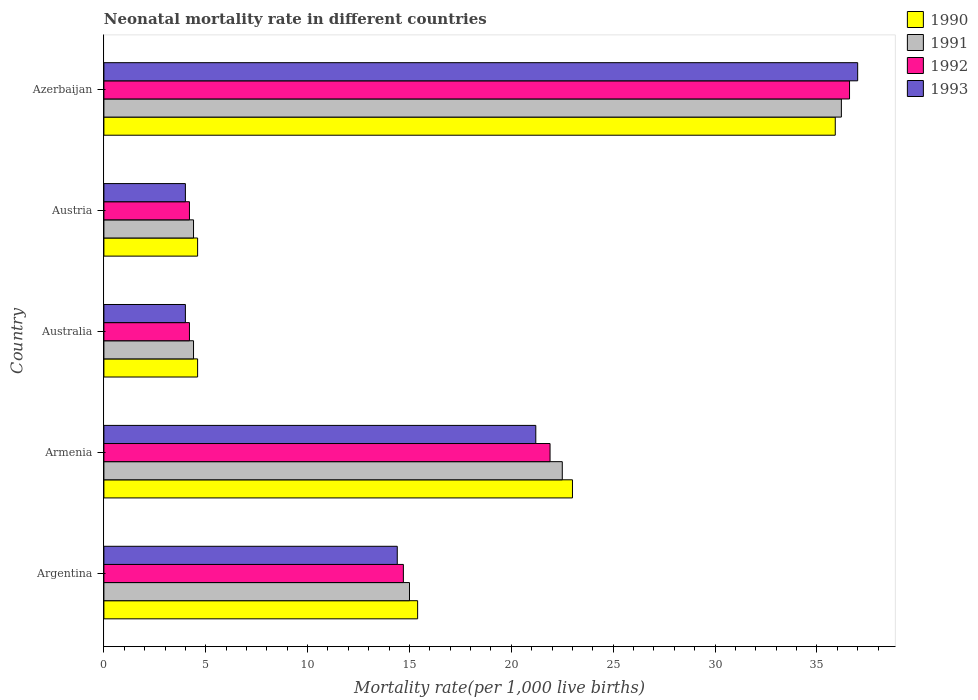How many different coloured bars are there?
Your answer should be very brief. 4. How many groups of bars are there?
Your response must be concise. 5. Are the number of bars per tick equal to the number of legend labels?
Keep it short and to the point. Yes. How many bars are there on the 3rd tick from the top?
Make the answer very short. 4. How many bars are there on the 4th tick from the bottom?
Your answer should be compact. 4. In how many cases, is the number of bars for a given country not equal to the number of legend labels?
Make the answer very short. 0. What is the neonatal mortality rate in 1992 in Australia?
Offer a terse response. 4.2. Across all countries, what is the maximum neonatal mortality rate in 1990?
Provide a short and direct response. 35.9. In which country was the neonatal mortality rate in 1993 maximum?
Make the answer very short. Azerbaijan. What is the total neonatal mortality rate in 1991 in the graph?
Your answer should be very brief. 82.5. What is the difference between the neonatal mortality rate in 1992 in Armenia and that in Austria?
Give a very brief answer. 17.7. What is the average neonatal mortality rate in 1993 per country?
Keep it short and to the point. 16.12. What is the difference between the neonatal mortality rate in 1993 and neonatal mortality rate in 1990 in Australia?
Make the answer very short. -0.6. In how many countries, is the neonatal mortality rate in 1992 greater than 22 ?
Provide a short and direct response. 1. What is the ratio of the neonatal mortality rate in 1992 in Argentina to that in Azerbaijan?
Give a very brief answer. 0.4. Is the difference between the neonatal mortality rate in 1993 in Armenia and Australia greater than the difference between the neonatal mortality rate in 1990 in Armenia and Australia?
Give a very brief answer. No. What is the difference between the highest and the second highest neonatal mortality rate in 1991?
Offer a terse response. 13.7. What is the difference between the highest and the lowest neonatal mortality rate in 1993?
Provide a succinct answer. 33. Is the sum of the neonatal mortality rate in 1991 in Austria and Azerbaijan greater than the maximum neonatal mortality rate in 1992 across all countries?
Make the answer very short. Yes. Is it the case that in every country, the sum of the neonatal mortality rate in 1992 and neonatal mortality rate in 1993 is greater than the sum of neonatal mortality rate in 1990 and neonatal mortality rate in 1991?
Provide a short and direct response. No. What does the 1st bar from the bottom in Armenia represents?
Provide a short and direct response. 1990. Does the graph contain any zero values?
Your response must be concise. No. Does the graph contain grids?
Your answer should be compact. No. Where does the legend appear in the graph?
Your response must be concise. Top right. What is the title of the graph?
Your answer should be compact. Neonatal mortality rate in different countries. Does "1992" appear as one of the legend labels in the graph?
Provide a succinct answer. Yes. What is the label or title of the X-axis?
Provide a succinct answer. Mortality rate(per 1,0 live births). What is the Mortality rate(per 1,000 live births) in 1991 in Argentina?
Give a very brief answer. 15. What is the Mortality rate(per 1,000 live births) of 1992 in Argentina?
Your answer should be very brief. 14.7. What is the Mortality rate(per 1,000 live births) of 1992 in Armenia?
Ensure brevity in your answer.  21.9. What is the Mortality rate(per 1,000 live births) in 1993 in Armenia?
Keep it short and to the point. 21.2. What is the Mortality rate(per 1,000 live births) of 1990 in Australia?
Provide a succinct answer. 4.6. What is the Mortality rate(per 1,000 live births) of 1992 in Australia?
Make the answer very short. 4.2. What is the Mortality rate(per 1,000 live births) in 1993 in Austria?
Ensure brevity in your answer.  4. What is the Mortality rate(per 1,000 live births) in 1990 in Azerbaijan?
Provide a short and direct response. 35.9. What is the Mortality rate(per 1,000 live births) of 1991 in Azerbaijan?
Your answer should be very brief. 36.2. What is the Mortality rate(per 1,000 live births) of 1992 in Azerbaijan?
Make the answer very short. 36.6. Across all countries, what is the maximum Mortality rate(per 1,000 live births) of 1990?
Ensure brevity in your answer.  35.9. Across all countries, what is the maximum Mortality rate(per 1,000 live births) of 1991?
Offer a terse response. 36.2. Across all countries, what is the maximum Mortality rate(per 1,000 live births) in 1992?
Ensure brevity in your answer.  36.6. Across all countries, what is the maximum Mortality rate(per 1,000 live births) of 1993?
Your answer should be very brief. 37. Across all countries, what is the minimum Mortality rate(per 1,000 live births) in 1990?
Ensure brevity in your answer.  4.6. Across all countries, what is the minimum Mortality rate(per 1,000 live births) in 1991?
Give a very brief answer. 4.4. Across all countries, what is the minimum Mortality rate(per 1,000 live births) in 1992?
Ensure brevity in your answer.  4.2. What is the total Mortality rate(per 1,000 live births) in 1990 in the graph?
Provide a succinct answer. 83.5. What is the total Mortality rate(per 1,000 live births) of 1991 in the graph?
Make the answer very short. 82.5. What is the total Mortality rate(per 1,000 live births) in 1992 in the graph?
Give a very brief answer. 81.6. What is the total Mortality rate(per 1,000 live births) in 1993 in the graph?
Make the answer very short. 80.6. What is the difference between the Mortality rate(per 1,000 live births) in 1990 in Argentina and that in Australia?
Your answer should be very brief. 10.8. What is the difference between the Mortality rate(per 1,000 live births) of 1992 in Argentina and that in Australia?
Make the answer very short. 10.5. What is the difference between the Mortality rate(per 1,000 live births) of 1990 in Argentina and that in Austria?
Ensure brevity in your answer.  10.8. What is the difference between the Mortality rate(per 1,000 live births) of 1991 in Argentina and that in Austria?
Provide a succinct answer. 10.6. What is the difference between the Mortality rate(per 1,000 live births) in 1992 in Argentina and that in Austria?
Offer a terse response. 10.5. What is the difference between the Mortality rate(per 1,000 live births) of 1993 in Argentina and that in Austria?
Your answer should be very brief. 10.4. What is the difference between the Mortality rate(per 1,000 live births) of 1990 in Argentina and that in Azerbaijan?
Offer a very short reply. -20.5. What is the difference between the Mortality rate(per 1,000 live births) of 1991 in Argentina and that in Azerbaijan?
Provide a succinct answer. -21.2. What is the difference between the Mortality rate(per 1,000 live births) in 1992 in Argentina and that in Azerbaijan?
Offer a very short reply. -21.9. What is the difference between the Mortality rate(per 1,000 live births) in 1993 in Argentina and that in Azerbaijan?
Your answer should be compact. -22.6. What is the difference between the Mortality rate(per 1,000 live births) of 1990 in Armenia and that in Australia?
Offer a very short reply. 18.4. What is the difference between the Mortality rate(per 1,000 live births) of 1991 in Armenia and that in Australia?
Keep it short and to the point. 18.1. What is the difference between the Mortality rate(per 1,000 live births) of 1992 in Armenia and that in Australia?
Provide a short and direct response. 17.7. What is the difference between the Mortality rate(per 1,000 live births) of 1993 in Armenia and that in Australia?
Offer a very short reply. 17.2. What is the difference between the Mortality rate(per 1,000 live births) of 1990 in Armenia and that in Austria?
Make the answer very short. 18.4. What is the difference between the Mortality rate(per 1,000 live births) in 1992 in Armenia and that in Austria?
Give a very brief answer. 17.7. What is the difference between the Mortality rate(per 1,000 live births) of 1993 in Armenia and that in Austria?
Offer a terse response. 17.2. What is the difference between the Mortality rate(per 1,000 live births) in 1991 in Armenia and that in Azerbaijan?
Make the answer very short. -13.7. What is the difference between the Mortality rate(per 1,000 live births) of 1992 in Armenia and that in Azerbaijan?
Provide a short and direct response. -14.7. What is the difference between the Mortality rate(per 1,000 live births) of 1993 in Armenia and that in Azerbaijan?
Offer a terse response. -15.8. What is the difference between the Mortality rate(per 1,000 live births) of 1990 in Australia and that in Austria?
Offer a terse response. 0. What is the difference between the Mortality rate(per 1,000 live births) of 1991 in Australia and that in Austria?
Make the answer very short. 0. What is the difference between the Mortality rate(per 1,000 live births) of 1992 in Australia and that in Austria?
Provide a short and direct response. 0. What is the difference between the Mortality rate(per 1,000 live births) in 1990 in Australia and that in Azerbaijan?
Give a very brief answer. -31.3. What is the difference between the Mortality rate(per 1,000 live births) of 1991 in Australia and that in Azerbaijan?
Ensure brevity in your answer.  -31.8. What is the difference between the Mortality rate(per 1,000 live births) in 1992 in Australia and that in Azerbaijan?
Ensure brevity in your answer.  -32.4. What is the difference between the Mortality rate(per 1,000 live births) in 1993 in Australia and that in Azerbaijan?
Your answer should be very brief. -33. What is the difference between the Mortality rate(per 1,000 live births) of 1990 in Austria and that in Azerbaijan?
Your answer should be very brief. -31.3. What is the difference between the Mortality rate(per 1,000 live births) of 1991 in Austria and that in Azerbaijan?
Provide a succinct answer. -31.8. What is the difference between the Mortality rate(per 1,000 live births) of 1992 in Austria and that in Azerbaijan?
Offer a very short reply. -32.4. What is the difference between the Mortality rate(per 1,000 live births) in 1993 in Austria and that in Azerbaijan?
Your response must be concise. -33. What is the difference between the Mortality rate(per 1,000 live births) in 1990 in Argentina and the Mortality rate(per 1,000 live births) in 1991 in Armenia?
Ensure brevity in your answer.  -7.1. What is the difference between the Mortality rate(per 1,000 live births) in 1990 in Argentina and the Mortality rate(per 1,000 live births) in 1993 in Armenia?
Your answer should be very brief. -5.8. What is the difference between the Mortality rate(per 1,000 live births) in 1991 in Argentina and the Mortality rate(per 1,000 live births) in 1992 in Armenia?
Ensure brevity in your answer.  -6.9. What is the difference between the Mortality rate(per 1,000 live births) of 1990 in Argentina and the Mortality rate(per 1,000 live births) of 1991 in Australia?
Make the answer very short. 11. What is the difference between the Mortality rate(per 1,000 live births) of 1990 in Argentina and the Mortality rate(per 1,000 live births) of 1992 in Australia?
Keep it short and to the point. 11.2. What is the difference between the Mortality rate(per 1,000 live births) in 1991 in Argentina and the Mortality rate(per 1,000 live births) in 1992 in Australia?
Provide a short and direct response. 10.8. What is the difference between the Mortality rate(per 1,000 live births) in 1992 in Argentina and the Mortality rate(per 1,000 live births) in 1993 in Australia?
Provide a short and direct response. 10.7. What is the difference between the Mortality rate(per 1,000 live births) of 1990 in Argentina and the Mortality rate(per 1,000 live births) of 1993 in Austria?
Offer a very short reply. 11.4. What is the difference between the Mortality rate(per 1,000 live births) of 1991 in Argentina and the Mortality rate(per 1,000 live births) of 1992 in Austria?
Provide a succinct answer. 10.8. What is the difference between the Mortality rate(per 1,000 live births) in 1991 in Argentina and the Mortality rate(per 1,000 live births) in 1993 in Austria?
Give a very brief answer. 11. What is the difference between the Mortality rate(per 1,000 live births) of 1990 in Argentina and the Mortality rate(per 1,000 live births) of 1991 in Azerbaijan?
Ensure brevity in your answer.  -20.8. What is the difference between the Mortality rate(per 1,000 live births) of 1990 in Argentina and the Mortality rate(per 1,000 live births) of 1992 in Azerbaijan?
Provide a short and direct response. -21.2. What is the difference between the Mortality rate(per 1,000 live births) in 1990 in Argentina and the Mortality rate(per 1,000 live births) in 1993 in Azerbaijan?
Give a very brief answer. -21.6. What is the difference between the Mortality rate(per 1,000 live births) in 1991 in Argentina and the Mortality rate(per 1,000 live births) in 1992 in Azerbaijan?
Offer a very short reply. -21.6. What is the difference between the Mortality rate(per 1,000 live births) of 1992 in Argentina and the Mortality rate(per 1,000 live births) of 1993 in Azerbaijan?
Ensure brevity in your answer.  -22.3. What is the difference between the Mortality rate(per 1,000 live births) of 1990 in Armenia and the Mortality rate(per 1,000 live births) of 1991 in Australia?
Ensure brevity in your answer.  18.6. What is the difference between the Mortality rate(per 1,000 live births) of 1991 in Armenia and the Mortality rate(per 1,000 live births) of 1993 in Australia?
Keep it short and to the point. 18.5. What is the difference between the Mortality rate(per 1,000 live births) in 1990 in Armenia and the Mortality rate(per 1,000 live births) in 1992 in Austria?
Your answer should be compact. 18.8. What is the difference between the Mortality rate(per 1,000 live births) in 1991 in Armenia and the Mortality rate(per 1,000 live births) in 1992 in Austria?
Provide a succinct answer. 18.3. What is the difference between the Mortality rate(per 1,000 live births) of 1991 in Armenia and the Mortality rate(per 1,000 live births) of 1993 in Austria?
Offer a very short reply. 18.5. What is the difference between the Mortality rate(per 1,000 live births) of 1992 in Armenia and the Mortality rate(per 1,000 live births) of 1993 in Austria?
Offer a terse response. 17.9. What is the difference between the Mortality rate(per 1,000 live births) of 1990 in Armenia and the Mortality rate(per 1,000 live births) of 1991 in Azerbaijan?
Provide a succinct answer. -13.2. What is the difference between the Mortality rate(per 1,000 live births) of 1991 in Armenia and the Mortality rate(per 1,000 live births) of 1992 in Azerbaijan?
Provide a short and direct response. -14.1. What is the difference between the Mortality rate(per 1,000 live births) in 1991 in Armenia and the Mortality rate(per 1,000 live births) in 1993 in Azerbaijan?
Your answer should be compact. -14.5. What is the difference between the Mortality rate(per 1,000 live births) in 1992 in Armenia and the Mortality rate(per 1,000 live births) in 1993 in Azerbaijan?
Make the answer very short. -15.1. What is the difference between the Mortality rate(per 1,000 live births) of 1990 in Australia and the Mortality rate(per 1,000 live births) of 1993 in Austria?
Your answer should be very brief. 0.6. What is the difference between the Mortality rate(per 1,000 live births) in 1991 in Australia and the Mortality rate(per 1,000 live births) in 1992 in Austria?
Provide a succinct answer. 0.2. What is the difference between the Mortality rate(per 1,000 live births) of 1991 in Australia and the Mortality rate(per 1,000 live births) of 1993 in Austria?
Make the answer very short. 0.4. What is the difference between the Mortality rate(per 1,000 live births) in 1990 in Australia and the Mortality rate(per 1,000 live births) in 1991 in Azerbaijan?
Your answer should be very brief. -31.6. What is the difference between the Mortality rate(per 1,000 live births) of 1990 in Australia and the Mortality rate(per 1,000 live births) of 1992 in Azerbaijan?
Keep it short and to the point. -32. What is the difference between the Mortality rate(per 1,000 live births) in 1990 in Australia and the Mortality rate(per 1,000 live births) in 1993 in Azerbaijan?
Offer a very short reply. -32.4. What is the difference between the Mortality rate(per 1,000 live births) of 1991 in Australia and the Mortality rate(per 1,000 live births) of 1992 in Azerbaijan?
Your response must be concise. -32.2. What is the difference between the Mortality rate(per 1,000 live births) of 1991 in Australia and the Mortality rate(per 1,000 live births) of 1993 in Azerbaijan?
Give a very brief answer. -32.6. What is the difference between the Mortality rate(per 1,000 live births) of 1992 in Australia and the Mortality rate(per 1,000 live births) of 1993 in Azerbaijan?
Offer a terse response. -32.8. What is the difference between the Mortality rate(per 1,000 live births) of 1990 in Austria and the Mortality rate(per 1,000 live births) of 1991 in Azerbaijan?
Make the answer very short. -31.6. What is the difference between the Mortality rate(per 1,000 live births) in 1990 in Austria and the Mortality rate(per 1,000 live births) in 1992 in Azerbaijan?
Make the answer very short. -32. What is the difference between the Mortality rate(per 1,000 live births) in 1990 in Austria and the Mortality rate(per 1,000 live births) in 1993 in Azerbaijan?
Your answer should be compact. -32.4. What is the difference between the Mortality rate(per 1,000 live births) in 1991 in Austria and the Mortality rate(per 1,000 live births) in 1992 in Azerbaijan?
Provide a short and direct response. -32.2. What is the difference between the Mortality rate(per 1,000 live births) in 1991 in Austria and the Mortality rate(per 1,000 live births) in 1993 in Azerbaijan?
Keep it short and to the point. -32.6. What is the difference between the Mortality rate(per 1,000 live births) of 1992 in Austria and the Mortality rate(per 1,000 live births) of 1993 in Azerbaijan?
Keep it short and to the point. -32.8. What is the average Mortality rate(per 1,000 live births) of 1992 per country?
Your answer should be very brief. 16.32. What is the average Mortality rate(per 1,000 live births) of 1993 per country?
Give a very brief answer. 16.12. What is the difference between the Mortality rate(per 1,000 live births) in 1990 and Mortality rate(per 1,000 live births) in 1991 in Argentina?
Offer a very short reply. 0.4. What is the difference between the Mortality rate(per 1,000 live births) in 1990 and Mortality rate(per 1,000 live births) in 1992 in Argentina?
Offer a terse response. 0.7. What is the difference between the Mortality rate(per 1,000 live births) in 1991 and Mortality rate(per 1,000 live births) in 1992 in Argentina?
Your response must be concise. 0.3. What is the difference between the Mortality rate(per 1,000 live births) of 1991 and Mortality rate(per 1,000 live births) of 1993 in Armenia?
Your response must be concise. 1.3. What is the difference between the Mortality rate(per 1,000 live births) in 1992 and Mortality rate(per 1,000 live births) in 1993 in Armenia?
Make the answer very short. 0.7. What is the difference between the Mortality rate(per 1,000 live births) in 1990 and Mortality rate(per 1,000 live births) in 1991 in Australia?
Keep it short and to the point. 0.2. What is the difference between the Mortality rate(per 1,000 live births) of 1991 and Mortality rate(per 1,000 live births) of 1992 in Australia?
Keep it short and to the point. 0.2. What is the difference between the Mortality rate(per 1,000 live births) of 1991 and Mortality rate(per 1,000 live births) of 1993 in Australia?
Your answer should be very brief. 0.4. What is the difference between the Mortality rate(per 1,000 live births) in 1992 and Mortality rate(per 1,000 live births) in 1993 in Australia?
Give a very brief answer. 0.2. What is the difference between the Mortality rate(per 1,000 live births) in 1991 and Mortality rate(per 1,000 live births) in 1993 in Austria?
Give a very brief answer. 0.4. What is the difference between the Mortality rate(per 1,000 live births) of 1990 and Mortality rate(per 1,000 live births) of 1991 in Azerbaijan?
Provide a short and direct response. -0.3. What is the difference between the Mortality rate(per 1,000 live births) of 1990 and Mortality rate(per 1,000 live births) of 1992 in Azerbaijan?
Your answer should be very brief. -0.7. What is the difference between the Mortality rate(per 1,000 live births) in 1992 and Mortality rate(per 1,000 live births) in 1993 in Azerbaijan?
Offer a terse response. -0.4. What is the ratio of the Mortality rate(per 1,000 live births) of 1990 in Argentina to that in Armenia?
Your answer should be compact. 0.67. What is the ratio of the Mortality rate(per 1,000 live births) of 1991 in Argentina to that in Armenia?
Provide a succinct answer. 0.67. What is the ratio of the Mortality rate(per 1,000 live births) in 1992 in Argentina to that in Armenia?
Your answer should be compact. 0.67. What is the ratio of the Mortality rate(per 1,000 live births) of 1993 in Argentina to that in Armenia?
Keep it short and to the point. 0.68. What is the ratio of the Mortality rate(per 1,000 live births) of 1990 in Argentina to that in Australia?
Your response must be concise. 3.35. What is the ratio of the Mortality rate(per 1,000 live births) in 1991 in Argentina to that in Australia?
Keep it short and to the point. 3.41. What is the ratio of the Mortality rate(per 1,000 live births) of 1990 in Argentina to that in Austria?
Keep it short and to the point. 3.35. What is the ratio of the Mortality rate(per 1,000 live births) of 1991 in Argentina to that in Austria?
Give a very brief answer. 3.41. What is the ratio of the Mortality rate(per 1,000 live births) in 1992 in Argentina to that in Austria?
Your answer should be very brief. 3.5. What is the ratio of the Mortality rate(per 1,000 live births) of 1990 in Argentina to that in Azerbaijan?
Keep it short and to the point. 0.43. What is the ratio of the Mortality rate(per 1,000 live births) of 1991 in Argentina to that in Azerbaijan?
Your response must be concise. 0.41. What is the ratio of the Mortality rate(per 1,000 live births) of 1992 in Argentina to that in Azerbaijan?
Provide a short and direct response. 0.4. What is the ratio of the Mortality rate(per 1,000 live births) in 1993 in Argentina to that in Azerbaijan?
Your response must be concise. 0.39. What is the ratio of the Mortality rate(per 1,000 live births) in 1991 in Armenia to that in Australia?
Your answer should be compact. 5.11. What is the ratio of the Mortality rate(per 1,000 live births) in 1992 in Armenia to that in Australia?
Make the answer very short. 5.21. What is the ratio of the Mortality rate(per 1,000 live births) in 1993 in Armenia to that in Australia?
Offer a very short reply. 5.3. What is the ratio of the Mortality rate(per 1,000 live births) of 1990 in Armenia to that in Austria?
Offer a terse response. 5. What is the ratio of the Mortality rate(per 1,000 live births) of 1991 in Armenia to that in Austria?
Offer a very short reply. 5.11. What is the ratio of the Mortality rate(per 1,000 live births) in 1992 in Armenia to that in Austria?
Keep it short and to the point. 5.21. What is the ratio of the Mortality rate(per 1,000 live births) of 1990 in Armenia to that in Azerbaijan?
Ensure brevity in your answer.  0.64. What is the ratio of the Mortality rate(per 1,000 live births) of 1991 in Armenia to that in Azerbaijan?
Make the answer very short. 0.62. What is the ratio of the Mortality rate(per 1,000 live births) in 1992 in Armenia to that in Azerbaijan?
Keep it short and to the point. 0.6. What is the ratio of the Mortality rate(per 1,000 live births) of 1993 in Armenia to that in Azerbaijan?
Provide a succinct answer. 0.57. What is the ratio of the Mortality rate(per 1,000 live births) in 1993 in Australia to that in Austria?
Provide a succinct answer. 1. What is the ratio of the Mortality rate(per 1,000 live births) in 1990 in Australia to that in Azerbaijan?
Your answer should be compact. 0.13. What is the ratio of the Mortality rate(per 1,000 live births) of 1991 in Australia to that in Azerbaijan?
Offer a very short reply. 0.12. What is the ratio of the Mortality rate(per 1,000 live births) of 1992 in Australia to that in Azerbaijan?
Your response must be concise. 0.11. What is the ratio of the Mortality rate(per 1,000 live births) of 1993 in Australia to that in Azerbaijan?
Ensure brevity in your answer.  0.11. What is the ratio of the Mortality rate(per 1,000 live births) of 1990 in Austria to that in Azerbaijan?
Provide a succinct answer. 0.13. What is the ratio of the Mortality rate(per 1,000 live births) in 1991 in Austria to that in Azerbaijan?
Provide a succinct answer. 0.12. What is the ratio of the Mortality rate(per 1,000 live births) of 1992 in Austria to that in Azerbaijan?
Make the answer very short. 0.11. What is the ratio of the Mortality rate(per 1,000 live births) of 1993 in Austria to that in Azerbaijan?
Your answer should be very brief. 0.11. What is the difference between the highest and the second highest Mortality rate(per 1,000 live births) of 1991?
Give a very brief answer. 13.7. What is the difference between the highest and the second highest Mortality rate(per 1,000 live births) of 1993?
Your answer should be compact. 15.8. What is the difference between the highest and the lowest Mortality rate(per 1,000 live births) in 1990?
Ensure brevity in your answer.  31.3. What is the difference between the highest and the lowest Mortality rate(per 1,000 live births) in 1991?
Provide a short and direct response. 31.8. What is the difference between the highest and the lowest Mortality rate(per 1,000 live births) in 1992?
Your answer should be very brief. 32.4. 